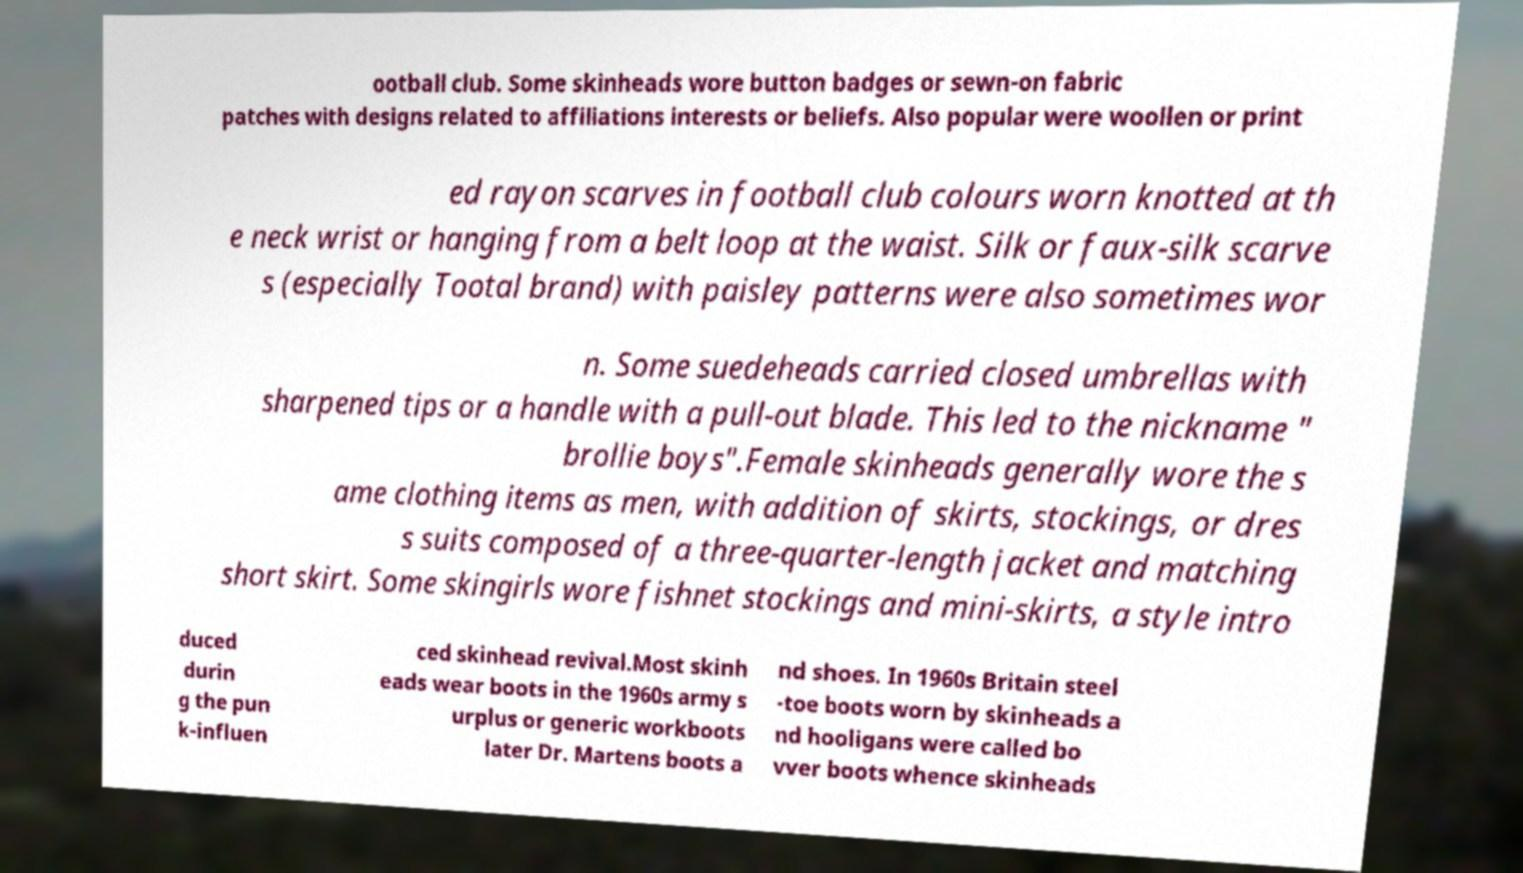For documentation purposes, I need the text within this image transcribed. Could you provide that? ootball club. Some skinheads wore button badges or sewn-on fabric patches with designs related to affiliations interests or beliefs. Also popular were woollen or print ed rayon scarves in football club colours worn knotted at th e neck wrist or hanging from a belt loop at the waist. Silk or faux-silk scarve s (especially Tootal brand) with paisley patterns were also sometimes wor n. Some suedeheads carried closed umbrellas with sharpened tips or a handle with a pull-out blade. This led to the nickname " brollie boys".Female skinheads generally wore the s ame clothing items as men, with addition of skirts, stockings, or dres s suits composed of a three-quarter-length jacket and matching short skirt. Some skingirls wore fishnet stockings and mini-skirts, a style intro duced durin g the pun k-influen ced skinhead revival.Most skinh eads wear boots in the 1960s army s urplus or generic workboots later Dr. Martens boots a nd shoes. In 1960s Britain steel -toe boots worn by skinheads a nd hooligans were called bo vver boots whence skinheads 